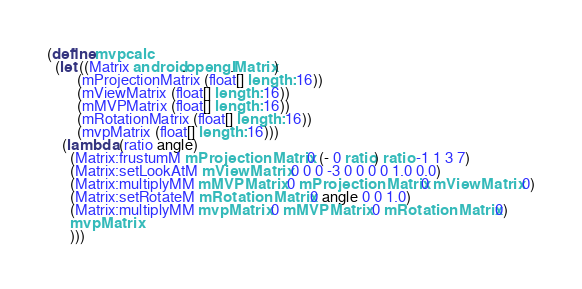<code> <loc_0><loc_0><loc_500><loc_500><_Scheme_>(define mvpcalc
  (let ((Matrix android.opengl.Matrix)
        (mProjectionMatrix (float[] length: 16))
        (mViewMatrix (float[] length: 16))
        (mMVPMatrix (float[] length: 16))
        (mRotationMatrix (float[] length: 16))
        (mvpMatrix (float[] length: 16)))
    (lambda (ratio angle)
      (Matrix:frustumM mProjectionMatrix 0 (- 0 ratio) ratio -1 1 3 7)
      (Matrix:setLookAtM mViewMatrix 0 0 0 -3 0 0 0 0 1.0 0.0)
      (Matrix:multiplyMM mMVPMatrix 0 mProjectionMatrix 0 mViewMatrix 0)
      (Matrix:setRotateM mRotationMatrix 0 angle 0 0 1.0)
      (Matrix:multiplyMM mvpMatrix 0 mMVPMatrix 0 mRotationMatrix 0)
      mvpMatrix
      )))
</code> 